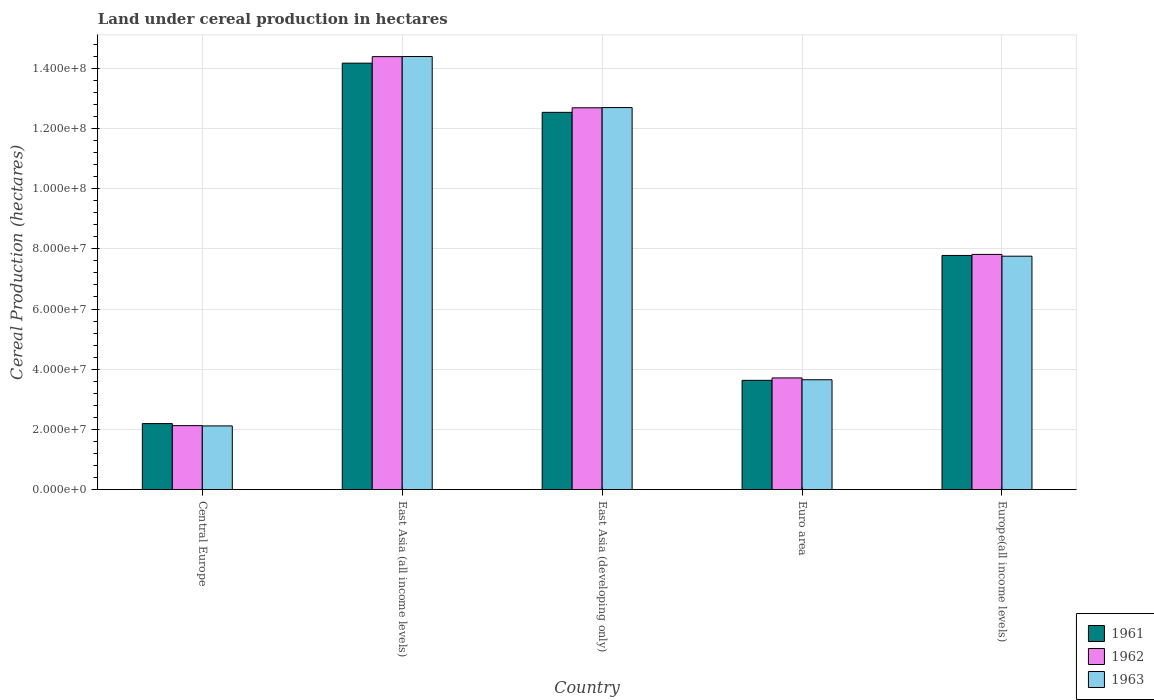How many different coloured bars are there?
Your answer should be compact. 3. What is the label of the 2nd group of bars from the left?
Offer a terse response. East Asia (all income levels). What is the land under cereal production in 1963 in Euro area?
Your answer should be very brief. 3.65e+07. Across all countries, what is the maximum land under cereal production in 1962?
Offer a very short reply. 1.44e+08. Across all countries, what is the minimum land under cereal production in 1962?
Keep it short and to the point. 2.12e+07. In which country was the land under cereal production in 1963 maximum?
Make the answer very short. East Asia (all income levels). In which country was the land under cereal production in 1961 minimum?
Ensure brevity in your answer.  Central Europe. What is the total land under cereal production in 1961 in the graph?
Your answer should be compact. 4.03e+08. What is the difference between the land under cereal production in 1963 in Central Europe and that in Europe(all income levels)?
Provide a short and direct response. -5.64e+07. What is the difference between the land under cereal production in 1963 in East Asia (all income levels) and the land under cereal production in 1961 in Europe(all income levels)?
Make the answer very short. 6.61e+07. What is the average land under cereal production in 1963 per country?
Offer a terse response. 8.12e+07. What is the difference between the land under cereal production of/in 1963 and land under cereal production of/in 1961 in Europe(all income levels)?
Keep it short and to the point. -2.50e+05. What is the ratio of the land under cereal production in 1961 in East Asia (all income levels) to that in East Asia (developing only)?
Provide a succinct answer. 1.13. What is the difference between the highest and the second highest land under cereal production in 1961?
Your response must be concise. -4.76e+07. What is the difference between the highest and the lowest land under cereal production in 1963?
Give a very brief answer. 1.23e+08. In how many countries, is the land under cereal production in 1963 greater than the average land under cereal production in 1963 taken over all countries?
Give a very brief answer. 2. Is the sum of the land under cereal production in 1963 in Euro area and Europe(all income levels) greater than the maximum land under cereal production in 1961 across all countries?
Give a very brief answer. No. Is it the case that in every country, the sum of the land under cereal production in 1963 and land under cereal production in 1961 is greater than the land under cereal production in 1962?
Offer a very short reply. Yes. Where does the legend appear in the graph?
Keep it short and to the point. Bottom right. How many legend labels are there?
Keep it short and to the point. 3. What is the title of the graph?
Keep it short and to the point. Land under cereal production in hectares. What is the label or title of the X-axis?
Your answer should be very brief. Country. What is the label or title of the Y-axis?
Offer a very short reply. Cereal Production (hectares). What is the Cereal Production (hectares) in 1961 in Central Europe?
Your response must be concise. 2.19e+07. What is the Cereal Production (hectares) in 1962 in Central Europe?
Your answer should be very brief. 2.12e+07. What is the Cereal Production (hectares) in 1963 in Central Europe?
Ensure brevity in your answer.  2.11e+07. What is the Cereal Production (hectares) of 1961 in East Asia (all income levels)?
Ensure brevity in your answer.  1.42e+08. What is the Cereal Production (hectares) of 1962 in East Asia (all income levels)?
Ensure brevity in your answer.  1.44e+08. What is the Cereal Production (hectares) in 1963 in East Asia (all income levels)?
Your response must be concise. 1.44e+08. What is the Cereal Production (hectares) in 1961 in East Asia (developing only)?
Give a very brief answer. 1.25e+08. What is the Cereal Production (hectares) in 1962 in East Asia (developing only)?
Ensure brevity in your answer.  1.27e+08. What is the Cereal Production (hectares) of 1963 in East Asia (developing only)?
Provide a succinct answer. 1.27e+08. What is the Cereal Production (hectares) in 1961 in Euro area?
Your answer should be very brief. 3.63e+07. What is the Cereal Production (hectares) of 1962 in Euro area?
Your answer should be very brief. 3.71e+07. What is the Cereal Production (hectares) in 1963 in Euro area?
Your answer should be compact. 3.65e+07. What is the Cereal Production (hectares) in 1961 in Europe(all income levels)?
Ensure brevity in your answer.  7.78e+07. What is the Cereal Production (hectares) of 1962 in Europe(all income levels)?
Ensure brevity in your answer.  7.82e+07. What is the Cereal Production (hectares) in 1963 in Europe(all income levels)?
Make the answer very short. 7.76e+07. Across all countries, what is the maximum Cereal Production (hectares) in 1961?
Your answer should be compact. 1.42e+08. Across all countries, what is the maximum Cereal Production (hectares) in 1962?
Your response must be concise. 1.44e+08. Across all countries, what is the maximum Cereal Production (hectares) in 1963?
Offer a terse response. 1.44e+08. Across all countries, what is the minimum Cereal Production (hectares) in 1961?
Give a very brief answer. 2.19e+07. Across all countries, what is the minimum Cereal Production (hectares) of 1962?
Your answer should be very brief. 2.12e+07. Across all countries, what is the minimum Cereal Production (hectares) in 1963?
Make the answer very short. 2.11e+07. What is the total Cereal Production (hectares) of 1961 in the graph?
Keep it short and to the point. 4.03e+08. What is the total Cereal Production (hectares) of 1962 in the graph?
Provide a succinct answer. 4.07e+08. What is the total Cereal Production (hectares) in 1963 in the graph?
Your answer should be compact. 4.06e+08. What is the difference between the Cereal Production (hectares) in 1961 in Central Europe and that in East Asia (all income levels)?
Your answer should be very brief. -1.20e+08. What is the difference between the Cereal Production (hectares) of 1962 in Central Europe and that in East Asia (all income levels)?
Your answer should be very brief. -1.23e+08. What is the difference between the Cereal Production (hectares) in 1963 in Central Europe and that in East Asia (all income levels)?
Give a very brief answer. -1.23e+08. What is the difference between the Cereal Production (hectares) in 1961 in Central Europe and that in East Asia (developing only)?
Ensure brevity in your answer.  -1.03e+08. What is the difference between the Cereal Production (hectares) in 1962 in Central Europe and that in East Asia (developing only)?
Provide a short and direct response. -1.06e+08. What is the difference between the Cereal Production (hectares) of 1963 in Central Europe and that in East Asia (developing only)?
Your response must be concise. -1.06e+08. What is the difference between the Cereal Production (hectares) in 1961 in Central Europe and that in Euro area?
Keep it short and to the point. -1.44e+07. What is the difference between the Cereal Production (hectares) of 1962 in Central Europe and that in Euro area?
Give a very brief answer. -1.59e+07. What is the difference between the Cereal Production (hectares) in 1963 in Central Europe and that in Euro area?
Ensure brevity in your answer.  -1.53e+07. What is the difference between the Cereal Production (hectares) of 1961 in Central Europe and that in Europe(all income levels)?
Your answer should be compact. -5.59e+07. What is the difference between the Cereal Production (hectares) of 1962 in Central Europe and that in Europe(all income levels)?
Offer a very short reply. -5.69e+07. What is the difference between the Cereal Production (hectares) of 1963 in Central Europe and that in Europe(all income levels)?
Provide a short and direct response. -5.64e+07. What is the difference between the Cereal Production (hectares) in 1961 in East Asia (all income levels) and that in East Asia (developing only)?
Offer a very short reply. 1.64e+07. What is the difference between the Cereal Production (hectares) of 1962 in East Asia (all income levels) and that in East Asia (developing only)?
Your answer should be compact. 1.70e+07. What is the difference between the Cereal Production (hectares) in 1963 in East Asia (all income levels) and that in East Asia (developing only)?
Provide a short and direct response. 1.70e+07. What is the difference between the Cereal Production (hectares) in 1961 in East Asia (all income levels) and that in Euro area?
Keep it short and to the point. 1.05e+08. What is the difference between the Cereal Production (hectares) in 1962 in East Asia (all income levels) and that in Euro area?
Your answer should be very brief. 1.07e+08. What is the difference between the Cereal Production (hectares) of 1963 in East Asia (all income levels) and that in Euro area?
Keep it short and to the point. 1.07e+08. What is the difference between the Cereal Production (hectares) in 1961 in East Asia (all income levels) and that in Europe(all income levels)?
Provide a short and direct response. 6.39e+07. What is the difference between the Cereal Production (hectares) in 1962 in East Asia (all income levels) and that in Europe(all income levels)?
Your answer should be very brief. 6.57e+07. What is the difference between the Cereal Production (hectares) in 1963 in East Asia (all income levels) and that in Europe(all income levels)?
Your response must be concise. 6.64e+07. What is the difference between the Cereal Production (hectares) of 1961 in East Asia (developing only) and that in Euro area?
Provide a succinct answer. 8.91e+07. What is the difference between the Cereal Production (hectares) in 1962 in East Asia (developing only) and that in Euro area?
Offer a terse response. 8.98e+07. What is the difference between the Cereal Production (hectares) in 1963 in East Asia (developing only) and that in Euro area?
Provide a short and direct response. 9.05e+07. What is the difference between the Cereal Production (hectares) of 1961 in East Asia (developing only) and that in Europe(all income levels)?
Your response must be concise. 4.76e+07. What is the difference between the Cereal Production (hectares) in 1962 in East Asia (developing only) and that in Europe(all income levels)?
Provide a succinct answer. 4.87e+07. What is the difference between the Cereal Production (hectares) of 1963 in East Asia (developing only) and that in Europe(all income levels)?
Make the answer very short. 4.94e+07. What is the difference between the Cereal Production (hectares) of 1961 in Euro area and that in Europe(all income levels)?
Provide a short and direct response. -4.15e+07. What is the difference between the Cereal Production (hectares) in 1962 in Euro area and that in Europe(all income levels)?
Your response must be concise. -4.11e+07. What is the difference between the Cereal Production (hectares) of 1963 in Euro area and that in Europe(all income levels)?
Offer a very short reply. -4.11e+07. What is the difference between the Cereal Production (hectares) in 1961 in Central Europe and the Cereal Production (hectares) in 1962 in East Asia (all income levels)?
Offer a terse response. -1.22e+08. What is the difference between the Cereal Production (hectares) of 1961 in Central Europe and the Cereal Production (hectares) of 1963 in East Asia (all income levels)?
Your answer should be very brief. -1.22e+08. What is the difference between the Cereal Production (hectares) in 1962 in Central Europe and the Cereal Production (hectares) in 1963 in East Asia (all income levels)?
Your response must be concise. -1.23e+08. What is the difference between the Cereal Production (hectares) of 1961 in Central Europe and the Cereal Production (hectares) of 1962 in East Asia (developing only)?
Your answer should be compact. -1.05e+08. What is the difference between the Cereal Production (hectares) in 1961 in Central Europe and the Cereal Production (hectares) in 1963 in East Asia (developing only)?
Ensure brevity in your answer.  -1.05e+08. What is the difference between the Cereal Production (hectares) of 1962 in Central Europe and the Cereal Production (hectares) of 1963 in East Asia (developing only)?
Give a very brief answer. -1.06e+08. What is the difference between the Cereal Production (hectares) in 1961 in Central Europe and the Cereal Production (hectares) in 1962 in Euro area?
Your answer should be compact. -1.52e+07. What is the difference between the Cereal Production (hectares) in 1961 in Central Europe and the Cereal Production (hectares) in 1963 in Euro area?
Give a very brief answer. -1.46e+07. What is the difference between the Cereal Production (hectares) in 1962 in Central Europe and the Cereal Production (hectares) in 1963 in Euro area?
Provide a short and direct response. -1.53e+07. What is the difference between the Cereal Production (hectares) of 1961 in Central Europe and the Cereal Production (hectares) of 1962 in Europe(all income levels)?
Your answer should be compact. -5.62e+07. What is the difference between the Cereal Production (hectares) in 1961 in Central Europe and the Cereal Production (hectares) in 1963 in Europe(all income levels)?
Provide a short and direct response. -5.56e+07. What is the difference between the Cereal Production (hectares) in 1962 in Central Europe and the Cereal Production (hectares) in 1963 in Europe(all income levels)?
Make the answer very short. -5.63e+07. What is the difference between the Cereal Production (hectares) in 1961 in East Asia (all income levels) and the Cereal Production (hectares) in 1962 in East Asia (developing only)?
Keep it short and to the point. 1.48e+07. What is the difference between the Cereal Production (hectares) in 1961 in East Asia (all income levels) and the Cereal Production (hectares) in 1963 in East Asia (developing only)?
Ensure brevity in your answer.  1.48e+07. What is the difference between the Cereal Production (hectares) of 1962 in East Asia (all income levels) and the Cereal Production (hectares) of 1963 in East Asia (developing only)?
Your answer should be very brief. 1.69e+07. What is the difference between the Cereal Production (hectares) of 1961 in East Asia (all income levels) and the Cereal Production (hectares) of 1962 in Euro area?
Give a very brief answer. 1.05e+08. What is the difference between the Cereal Production (hectares) in 1961 in East Asia (all income levels) and the Cereal Production (hectares) in 1963 in Euro area?
Ensure brevity in your answer.  1.05e+08. What is the difference between the Cereal Production (hectares) in 1962 in East Asia (all income levels) and the Cereal Production (hectares) in 1963 in Euro area?
Make the answer very short. 1.07e+08. What is the difference between the Cereal Production (hectares) in 1961 in East Asia (all income levels) and the Cereal Production (hectares) in 1962 in Europe(all income levels)?
Your response must be concise. 6.36e+07. What is the difference between the Cereal Production (hectares) of 1961 in East Asia (all income levels) and the Cereal Production (hectares) of 1963 in Europe(all income levels)?
Provide a succinct answer. 6.42e+07. What is the difference between the Cereal Production (hectares) of 1962 in East Asia (all income levels) and the Cereal Production (hectares) of 1963 in Europe(all income levels)?
Your answer should be compact. 6.63e+07. What is the difference between the Cereal Production (hectares) of 1961 in East Asia (developing only) and the Cereal Production (hectares) of 1962 in Euro area?
Your answer should be very brief. 8.83e+07. What is the difference between the Cereal Production (hectares) in 1961 in East Asia (developing only) and the Cereal Production (hectares) in 1963 in Euro area?
Offer a very short reply. 8.89e+07. What is the difference between the Cereal Production (hectares) of 1962 in East Asia (developing only) and the Cereal Production (hectares) of 1963 in Euro area?
Offer a terse response. 9.04e+07. What is the difference between the Cereal Production (hectares) in 1961 in East Asia (developing only) and the Cereal Production (hectares) in 1962 in Europe(all income levels)?
Make the answer very short. 4.72e+07. What is the difference between the Cereal Production (hectares) in 1961 in East Asia (developing only) and the Cereal Production (hectares) in 1963 in Europe(all income levels)?
Keep it short and to the point. 4.78e+07. What is the difference between the Cereal Production (hectares) in 1962 in East Asia (developing only) and the Cereal Production (hectares) in 1963 in Europe(all income levels)?
Your response must be concise. 4.93e+07. What is the difference between the Cereal Production (hectares) in 1961 in Euro area and the Cereal Production (hectares) in 1962 in Europe(all income levels)?
Your response must be concise. -4.19e+07. What is the difference between the Cereal Production (hectares) in 1961 in Euro area and the Cereal Production (hectares) in 1963 in Europe(all income levels)?
Keep it short and to the point. -4.13e+07. What is the difference between the Cereal Production (hectares) in 1962 in Euro area and the Cereal Production (hectares) in 1963 in Europe(all income levels)?
Your response must be concise. -4.05e+07. What is the average Cereal Production (hectares) in 1961 per country?
Provide a succinct answer. 8.06e+07. What is the average Cereal Production (hectares) of 1962 per country?
Provide a succinct answer. 8.15e+07. What is the average Cereal Production (hectares) in 1963 per country?
Give a very brief answer. 8.12e+07. What is the difference between the Cereal Production (hectares) of 1961 and Cereal Production (hectares) of 1962 in Central Europe?
Give a very brief answer. 6.84e+05. What is the difference between the Cereal Production (hectares) in 1961 and Cereal Production (hectares) in 1963 in Central Europe?
Your answer should be compact. 7.75e+05. What is the difference between the Cereal Production (hectares) in 1962 and Cereal Production (hectares) in 1963 in Central Europe?
Your answer should be very brief. 9.14e+04. What is the difference between the Cereal Production (hectares) in 1961 and Cereal Production (hectares) in 1962 in East Asia (all income levels)?
Make the answer very short. -2.17e+06. What is the difference between the Cereal Production (hectares) in 1961 and Cereal Production (hectares) in 1963 in East Asia (all income levels)?
Make the answer very short. -2.21e+06. What is the difference between the Cereal Production (hectares) in 1962 and Cereal Production (hectares) in 1963 in East Asia (all income levels)?
Your answer should be very brief. -3.63e+04. What is the difference between the Cereal Production (hectares) of 1961 and Cereal Production (hectares) of 1962 in East Asia (developing only)?
Ensure brevity in your answer.  -1.52e+06. What is the difference between the Cereal Production (hectares) in 1961 and Cereal Production (hectares) in 1963 in East Asia (developing only)?
Give a very brief answer. -1.59e+06. What is the difference between the Cereal Production (hectares) of 1962 and Cereal Production (hectares) of 1963 in East Asia (developing only)?
Offer a very short reply. -7.11e+04. What is the difference between the Cereal Production (hectares) in 1961 and Cereal Production (hectares) in 1962 in Euro area?
Give a very brief answer. -8.01e+05. What is the difference between the Cereal Production (hectares) in 1961 and Cereal Production (hectares) in 1963 in Euro area?
Ensure brevity in your answer.  -1.95e+05. What is the difference between the Cereal Production (hectares) in 1962 and Cereal Production (hectares) in 1963 in Euro area?
Offer a terse response. 6.06e+05. What is the difference between the Cereal Production (hectares) of 1961 and Cereal Production (hectares) of 1962 in Europe(all income levels)?
Give a very brief answer. -3.44e+05. What is the difference between the Cereal Production (hectares) of 1961 and Cereal Production (hectares) of 1963 in Europe(all income levels)?
Ensure brevity in your answer.  2.50e+05. What is the difference between the Cereal Production (hectares) in 1962 and Cereal Production (hectares) in 1963 in Europe(all income levels)?
Provide a short and direct response. 5.94e+05. What is the ratio of the Cereal Production (hectares) in 1961 in Central Europe to that in East Asia (all income levels)?
Offer a very short reply. 0.15. What is the ratio of the Cereal Production (hectares) of 1962 in Central Europe to that in East Asia (all income levels)?
Ensure brevity in your answer.  0.15. What is the ratio of the Cereal Production (hectares) of 1963 in Central Europe to that in East Asia (all income levels)?
Provide a short and direct response. 0.15. What is the ratio of the Cereal Production (hectares) of 1961 in Central Europe to that in East Asia (developing only)?
Offer a terse response. 0.17. What is the ratio of the Cereal Production (hectares) in 1962 in Central Europe to that in East Asia (developing only)?
Your answer should be compact. 0.17. What is the ratio of the Cereal Production (hectares) in 1963 in Central Europe to that in East Asia (developing only)?
Provide a short and direct response. 0.17. What is the ratio of the Cereal Production (hectares) of 1961 in Central Europe to that in Euro area?
Ensure brevity in your answer.  0.6. What is the ratio of the Cereal Production (hectares) of 1962 in Central Europe to that in Euro area?
Make the answer very short. 0.57. What is the ratio of the Cereal Production (hectares) in 1963 in Central Europe to that in Euro area?
Your response must be concise. 0.58. What is the ratio of the Cereal Production (hectares) in 1961 in Central Europe to that in Europe(all income levels)?
Ensure brevity in your answer.  0.28. What is the ratio of the Cereal Production (hectares) of 1962 in Central Europe to that in Europe(all income levels)?
Provide a short and direct response. 0.27. What is the ratio of the Cereal Production (hectares) of 1963 in Central Europe to that in Europe(all income levels)?
Your answer should be compact. 0.27. What is the ratio of the Cereal Production (hectares) of 1961 in East Asia (all income levels) to that in East Asia (developing only)?
Provide a succinct answer. 1.13. What is the ratio of the Cereal Production (hectares) in 1962 in East Asia (all income levels) to that in East Asia (developing only)?
Provide a succinct answer. 1.13. What is the ratio of the Cereal Production (hectares) in 1963 in East Asia (all income levels) to that in East Asia (developing only)?
Offer a very short reply. 1.13. What is the ratio of the Cereal Production (hectares) of 1961 in East Asia (all income levels) to that in Euro area?
Your answer should be compact. 3.91. What is the ratio of the Cereal Production (hectares) in 1962 in East Asia (all income levels) to that in Euro area?
Give a very brief answer. 3.88. What is the ratio of the Cereal Production (hectares) of 1963 in East Asia (all income levels) to that in Euro area?
Provide a succinct answer. 3.94. What is the ratio of the Cereal Production (hectares) of 1961 in East Asia (all income levels) to that in Europe(all income levels)?
Keep it short and to the point. 1.82. What is the ratio of the Cereal Production (hectares) in 1962 in East Asia (all income levels) to that in Europe(all income levels)?
Make the answer very short. 1.84. What is the ratio of the Cereal Production (hectares) in 1963 in East Asia (all income levels) to that in Europe(all income levels)?
Your answer should be compact. 1.86. What is the ratio of the Cereal Production (hectares) in 1961 in East Asia (developing only) to that in Euro area?
Provide a short and direct response. 3.45. What is the ratio of the Cereal Production (hectares) of 1962 in East Asia (developing only) to that in Euro area?
Your answer should be compact. 3.42. What is the ratio of the Cereal Production (hectares) of 1963 in East Asia (developing only) to that in Euro area?
Provide a succinct answer. 3.48. What is the ratio of the Cereal Production (hectares) in 1961 in East Asia (developing only) to that in Europe(all income levels)?
Offer a very short reply. 1.61. What is the ratio of the Cereal Production (hectares) of 1962 in East Asia (developing only) to that in Europe(all income levels)?
Make the answer very short. 1.62. What is the ratio of the Cereal Production (hectares) in 1963 in East Asia (developing only) to that in Europe(all income levels)?
Provide a short and direct response. 1.64. What is the ratio of the Cereal Production (hectares) in 1961 in Euro area to that in Europe(all income levels)?
Keep it short and to the point. 0.47. What is the ratio of the Cereal Production (hectares) of 1962 in Euro area to that in Europe(all income levels)?
Provide a succinct answer. 0.47. What is the ratio of the Cereal Production (hectares) of 1963 in Euro area to that in Europe(all income levels)?
Give a very brief answer. 0.47. What is the difference between the highest and the second highest Cereal Production (hectares) in 1961?
Ensure brevity in your answer.  1.64e+07. What is the difference between the highest and the second highest Cereal Production (hectares) of 1962?
Your answer should be compact. 1.70e+07. What is the difference between the highest and the second highest Cereal Production (hectares) in 1963?
Your answer should be compact. 1.70e+07. What is the difference between the highest and the lowest Cereal Production (hectares) in 1961?
Your answer should be compact. 1.20e+08. What is the difference between the highest and the lowest Cereal Production (hectares) of 1962?
Your answer should be compact. 1.23e+08. What is the difference between the highest and the lowest Cereal Production (hectares) in 1963?
Offer a terse response. 1.23e+08. 